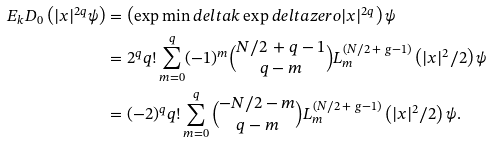Convert formula to latex. <formula><loc_0><loc_0><loc_500><loc_500>E _ { k } D _ { 0 } \left ( | x | ^ { 2 q } \psi \right ) & = \left ( \exp \min d e l t a k \exp d e l t a z e r o | x | ^ { 2 q } \right ) \psi \\ & = 2 ^ { q } q ! \sum _ { m = 0 } ^ { q } ( - 1 ) ^ { m } { N / 2 \, + q - 1 \choose q - m } L _ { m } ^ { ( N / 2 \, + \ g - 1 ) } \left ( | x | ^ { 2 } / 2 \right ) \psi \\ & = ( - 2 ) ^ { q } q ! \sum _ { m = 0 } ^ { q } { - N / 2 - m \choose q - m } L _ { m } ^ { ( N / 2 \, + \ g - 1 ) } \left ( | x | ^ { 2 } / 2 \right ) \psi .</formula> 